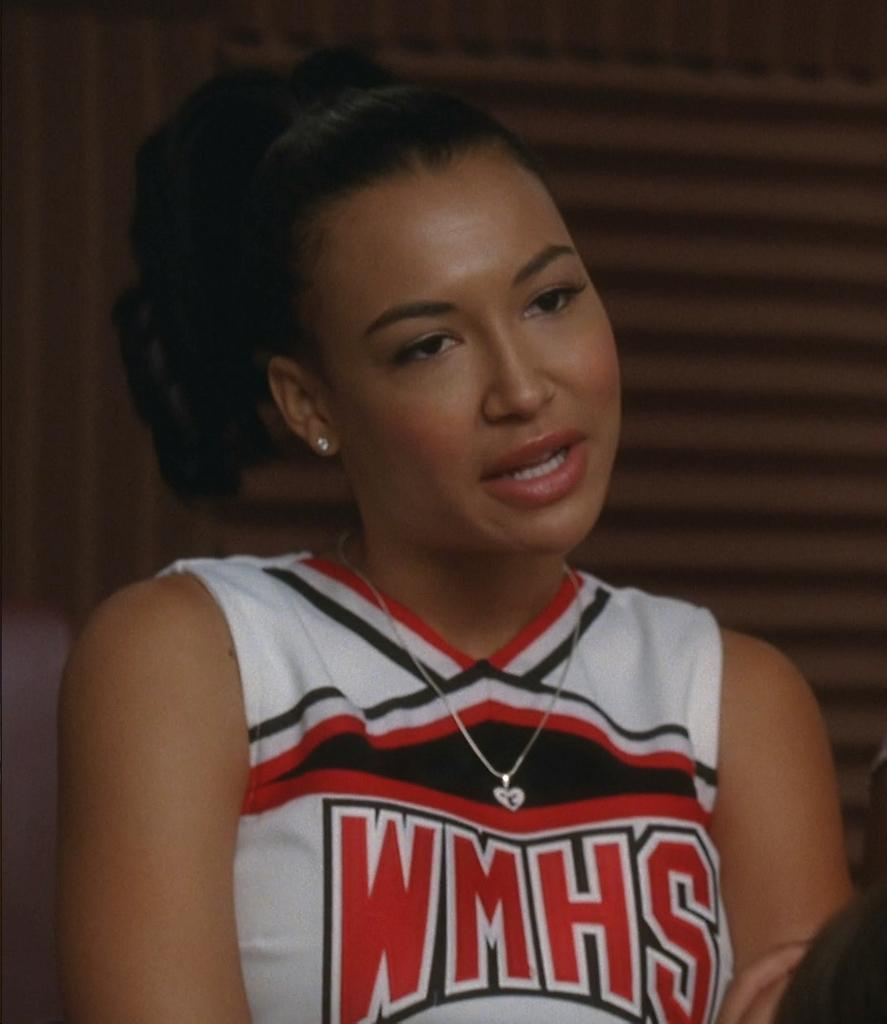<image>
Give a short and clear explanation of the subsequent image. A girl from Glee wearing a cheerleader uniform that says WMHS. 